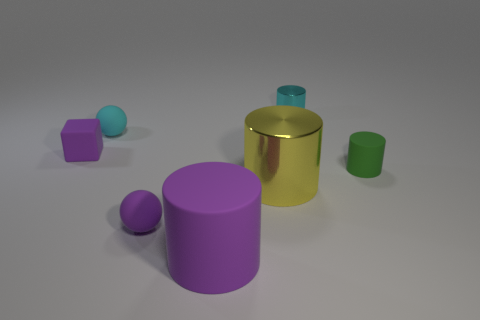Add 3 tiny purple rubber blocks. How many objects exist? 10 Subtract all large purple cylinders. How many cylinders are left? 3 Subtract all purple balls. How many balls are left? 1 Add 3 yellow things. How many yellow things are left? 4 Add 6 big purple matte objects. How many big purple matte objects exist? 7 Subtract 1 purple cubes. How many objects are left? 6 Subtract all cylinders. How many objects are left? 3 Subtract 2 spheres. How many spheres are left? 0 Subtract all gray cylinders. Subtract all red spheres. How many cylinders are left? 4 Subtract all gray cubes. How many gray balls are left? 0 